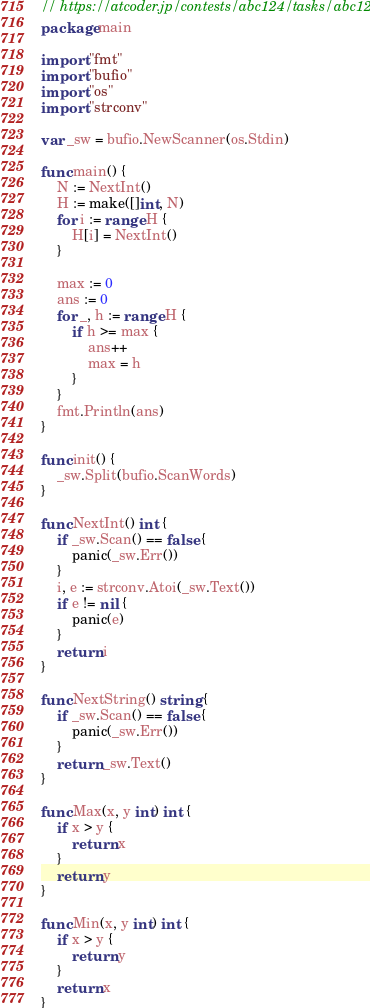Convert code to text. <code><loc_0><loc_0><loc_500><loc_500><_Go_>// https://atcoder.jp/contests/abc124/tasks/abc124_b
package main

import "fmt"
import "bufio"
import "os"
import "strconv"

var _sw = bufio.NewScanner(os.Stdin)

func main() {
	N := NextInt()
	H := make([]int, N)
	for i := range H {
		H[i] = NextInt()
	}

	max := 0
	ans := 0
	for _, h := range H {
		if h >= max {
			ans++
			max = h
		}
	}
	fmt.Println(ans)
}

func init() {
	_sw.Split(bufio.ScanWords)
}

func NextInt() int {
	if _sw.Scan() == false {
		panic(_sw.Err())
	}
	i, e := strconv.Atoi(_sw.Text())
	if e != nil {
		panic(e)
	}
	return i
}

func NextString() string {
	if _sw.Scan() == false {
		panic(_sw.Err())
	}
	return _sw.Text()
}

func Max(x, y int) int {
	if x > y {
		return x
	}
	return y
}

func Min(x, y int) int {
	if x > y {
		return y
	}
	return x
}
</code> 